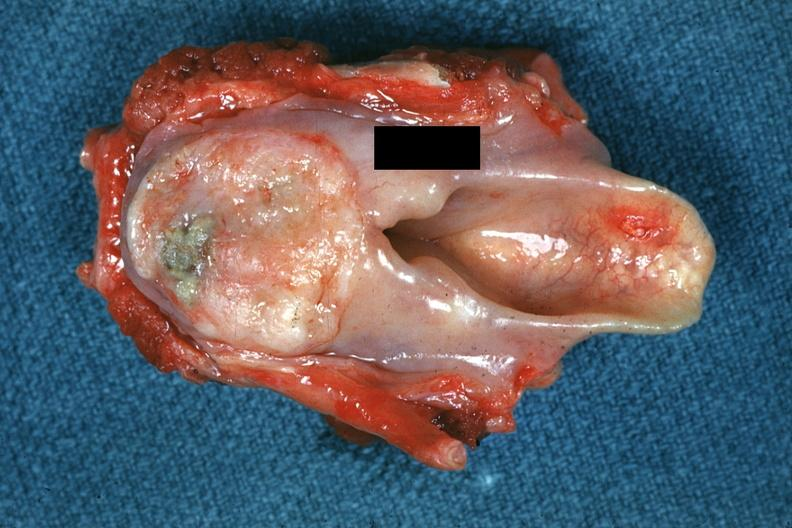what is present?
Answer the question using a single word or phrase. Squamous cell carcinoma 